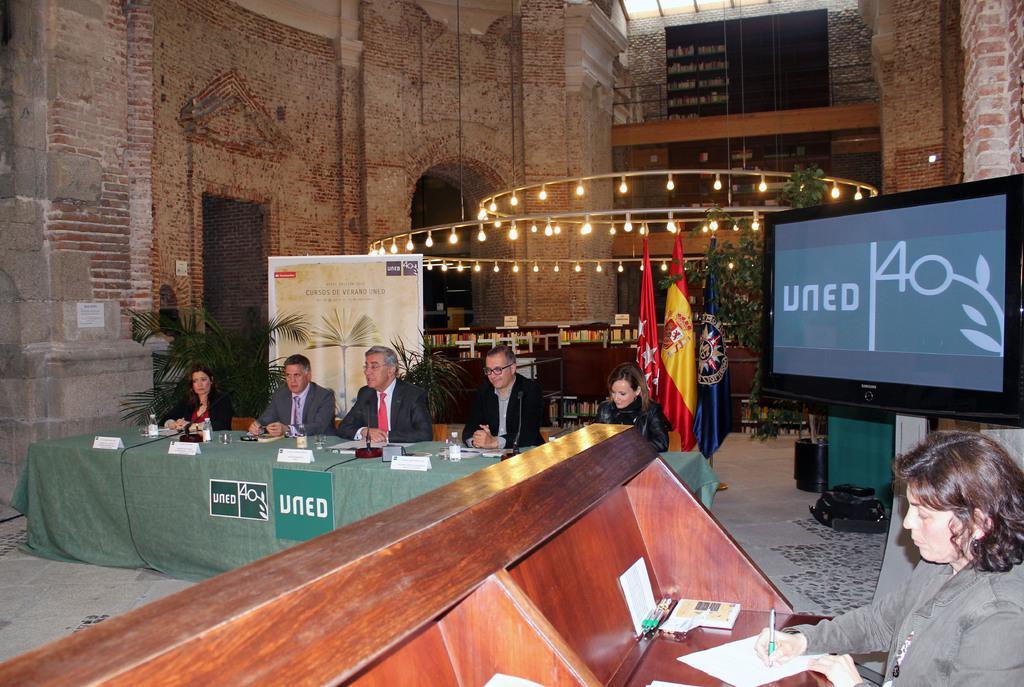Can you describe this image briefly? in the room,there are many people having a conference,they are sitting on the chairs in front of them there was a big table,on the table there are different items ,the room was decorated with the lights flags and in the room there was led screen and also a small plants which are used for the decorative purpose. 